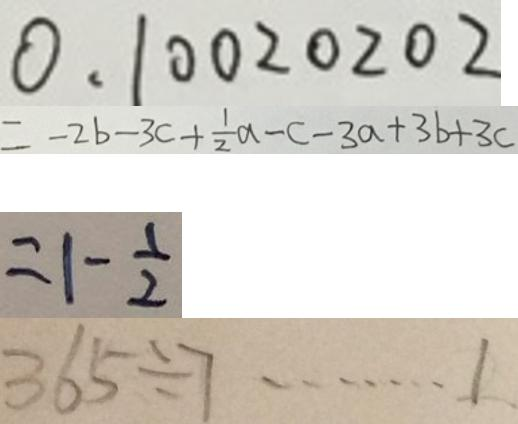<formula> <loc_0><loc_0><loc_500><loc_500>0 . 1 0 0 2 0 2 0 2 
 = - 2 b - 3 c + \frac { 1 } { 2 } a - c - 3 a + 3 b + 3 c 
 = 1 - \frac { 1 } { 2 } 
 3 6 5 \div 7 \cdots 1 .</formula> 